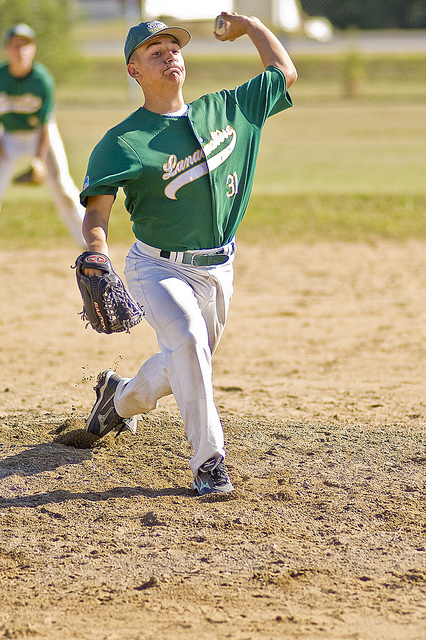<image>What brand of glove is the player using? I don't know what brand of glove the player is using. It can be 'Eastbay', 'Nike', 'Hall', 'Easton', 'Wilson', 'Little Slugger', or 'Ford'. What brand of glove is the player using? I don't know the brand of glove the player is using. It can be seen 'eastbay', 'nike', 'hall', 'unknown', 'easton', 'wilson', 'little slugger' or 'ford'. 